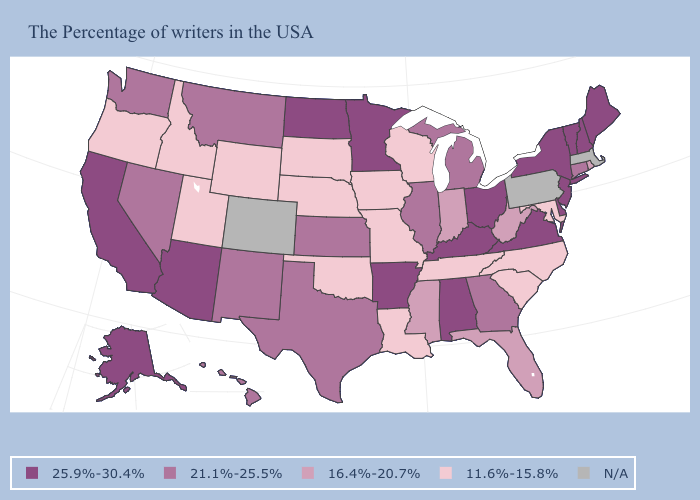Does Nebraska have the lowest value in the USA?
Give a very brief answer. Yes. Is the legend a continuous bar?
Write a very short answer. No. What is the lowest value in the MidWest?
Quick response, please. 11.6%-15.8%. Name the states that have a value in the range N/A?
Give a very brief answer. Massachusetts, Pennsylvania, Colorado. Among the states that border New Mexico , which have the lowest value?
Keep it brief. Oklahoma, Utah. Does the first symbol in the legend represent the smallest category?
Give a very brief answer. No. Does the map have missing data?
Write a very short answer. Yes. Does Utah have the lowest value in the West?
Short answer required. Yes. What is the value of Maine?
Give a very brief answer. 25.9%-30.4%. Which states have the highest value in the USA?
Write a very short answer. Maine, New Hampshire, Vermont, New York, New Jersey, Delaware, Virginia, Ohio, Kentucky, Alabama, Arkansas, Minnesota, North Dakota, Arizona, California, Alaska. Among the states that border North Dakota , does Minnesota have the highest value?
Give a very brief answer. Yes. Name the states that have a value in the range N/A?
Give a very brief answer. Massachusetts, Pennsylvania, Colorado. What is the value of Pennsylvania?
Quick response, please. N/A. 